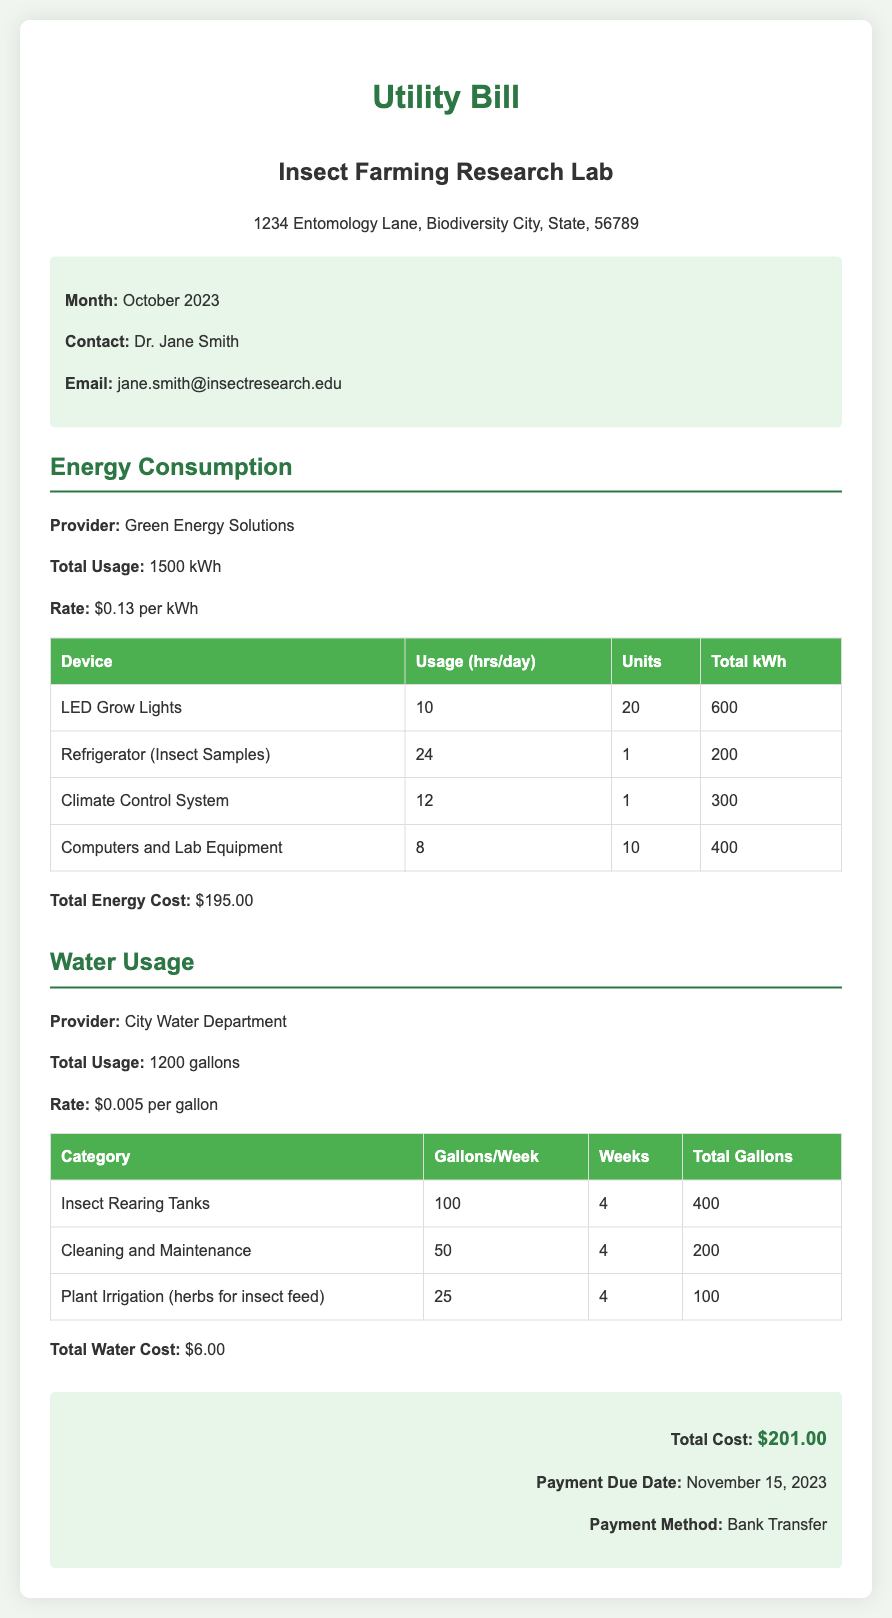What is the total energy usage? The total energy usage is explicitly mentioned in the document as 1500 kWh.
Answer: 1500 kWh What is the rate per gallon for water? The rate for water is provided in the document as $0.005 per gallon.
Answer: $0.005 How many weeks were considered for calculating water usage? The document states that calculations were made for 4 weeks in total.
Answer: 4 What is the name of the energy provider? The energy provider's name is mentioned as Green Energy Solutions in the document.
Answer: Green Energy Solutions How much did the lab spend on total water? The total cost for water is indicated as $6.00 in the document.
Answer: $6.00 What is the payment due date? The due date for payment is clearly outlined as November 15, 2023.
Answer: November 15, 2023 How many gallons were used for plant irrigation? The document shows that 100 gallons were used for plant irrigation over the specified weeks.
Answer: 100 gallons What devices are consuming the most energy in the lab? The device consuming the most energy is the LED Grow Lights, totaling 600 kWh.
Answer: LED Grow Lights What is the total cost including energy and water? The total cost, which includes both energy and water expenses, is stated as $201.00.
Answer: $201.00 